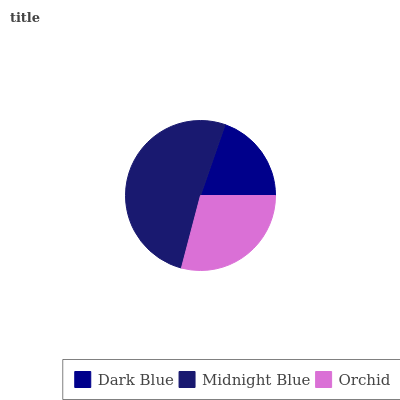Is Dark Blue the minimum?
Answer yes or no. Yes. Is Midnight Blue the maximum?
Answer yes or no. Yes. Is Orchid the minimum?
Answer yes or no. No. Is Orchid the maximum?
Answer yes or no. No. Is Midnight Blue greater than Orchid?
Answer yes or no. Yes. Is Orchid less than Midnight Blue?
Answer yes or no. Yes. Is Orchid greater than Midnight Blue?
Answer yes or no. No. Is Midnight Blue less than Orchid?
Answer yes or no. No. Is Orchid the high median?
Answer yes or no. Yes. Is Orchid the low median?
Answer yes or no. Yes. Is Midnight Blue the high median?
Answer yes or no. No. Is Midnight Blue the low median?
Answer yes or no. No. 